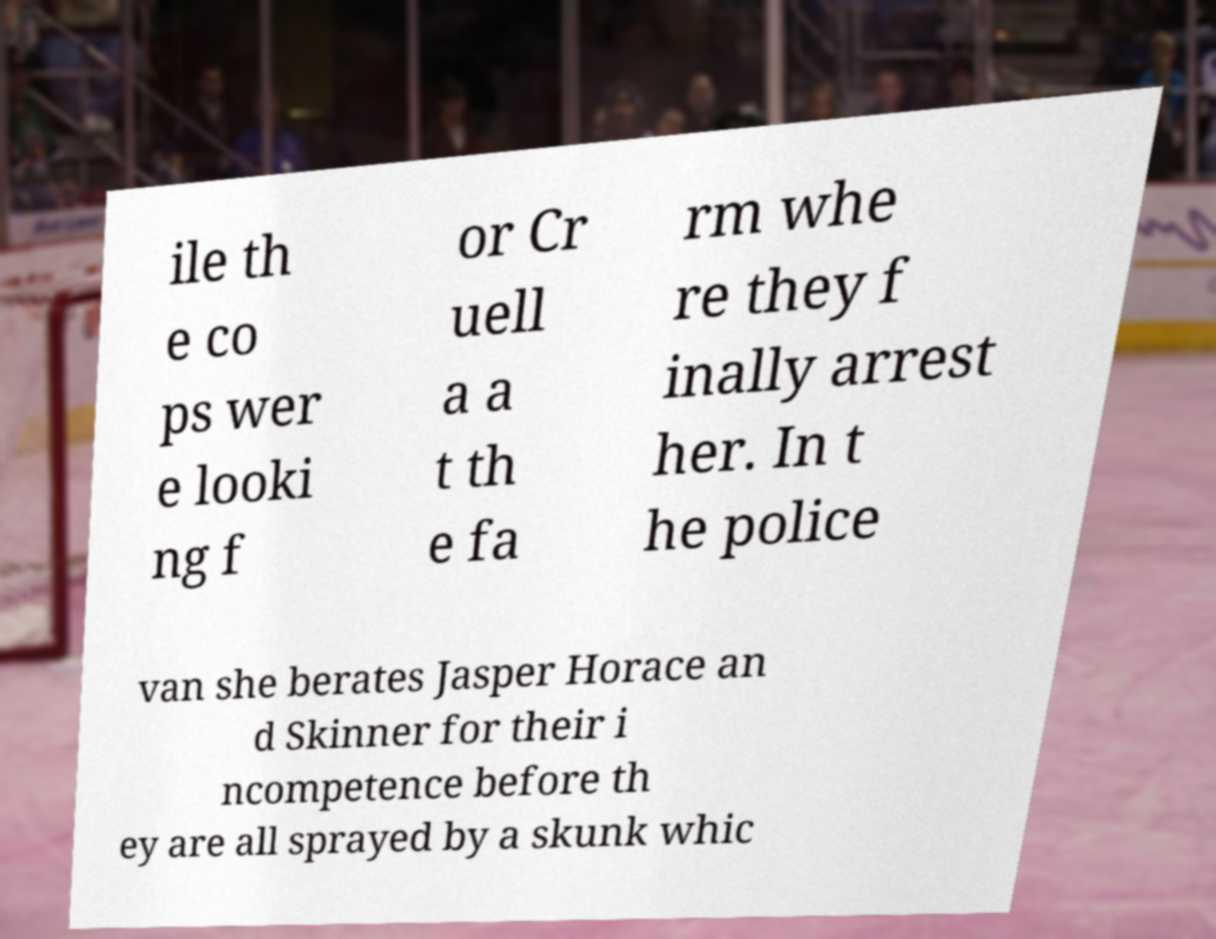What messages or text are displayed in this image? I need them in a readable, typed format. ile th e co ps wer e looki ng f or Cr uell a a t th e fa rm whe re they f inally arrest her. In t he police van she berates Jasper Horace an d Skinner for their i ncompetence before th ey are all sprayed by a skunk whic 